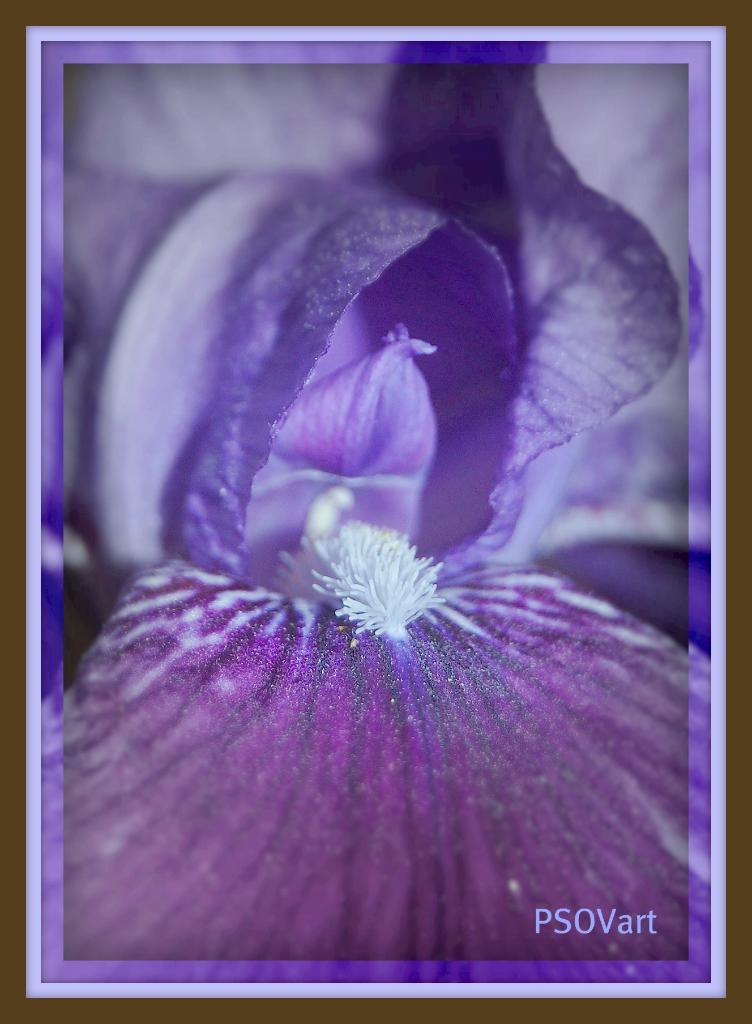What object can be seen in the image that typically holds a photograph? There is a photo frame in the image. What type of natural elements are visible in the image? Flower petals are visible in the image. Where is the text located in the image? The text is in the bottom right corner of the image. How many cattle can be seen grazing in the image? There are no cattle present in the image. What type of produce is being harvested in the image? There is no produce being harvested in the image. 